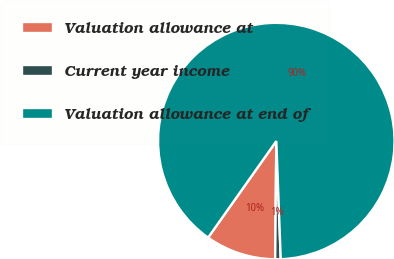<chart> <loc_0><loc_0><loc_500><loc_500><pie_chart><fcel>Valuation allowance at<fcel>Current year income<fcel>Valuation allowance at end of<nl><fcel>9.64%<fcel>0.75%<fcel>89.61%<nl></chart> 